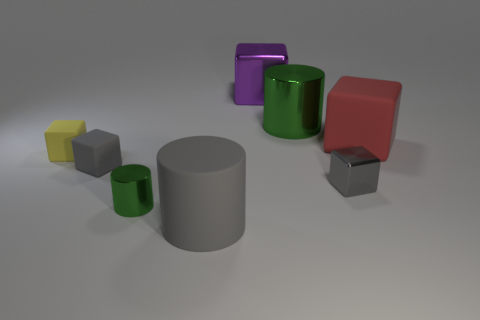Subtract 2 cylinders. How many cylinders are left? 1 Subtract all big green metallic cylinders. How many cylinders are left? 2 Add 2 large yellow rubber cylinders. How many large yellow rubber cylinders exist? 2 Add 1 tiny green things. How many objects exist? 9 Subtract all purple cubes. How many cubes are left? 4 Subtract 0 brown cubes. How many objects are left? 8 Subtract all cubes. How many objects are left? 3 Subtract all cyan cylinders. Subtract all yellow blocks. How many cylinders are left? 3 Subtract all gray blocks. How many green cylinders are left? 2 Subtract all red rubber objects. Subtract all green metal cylinders. How many objects are left? 5 